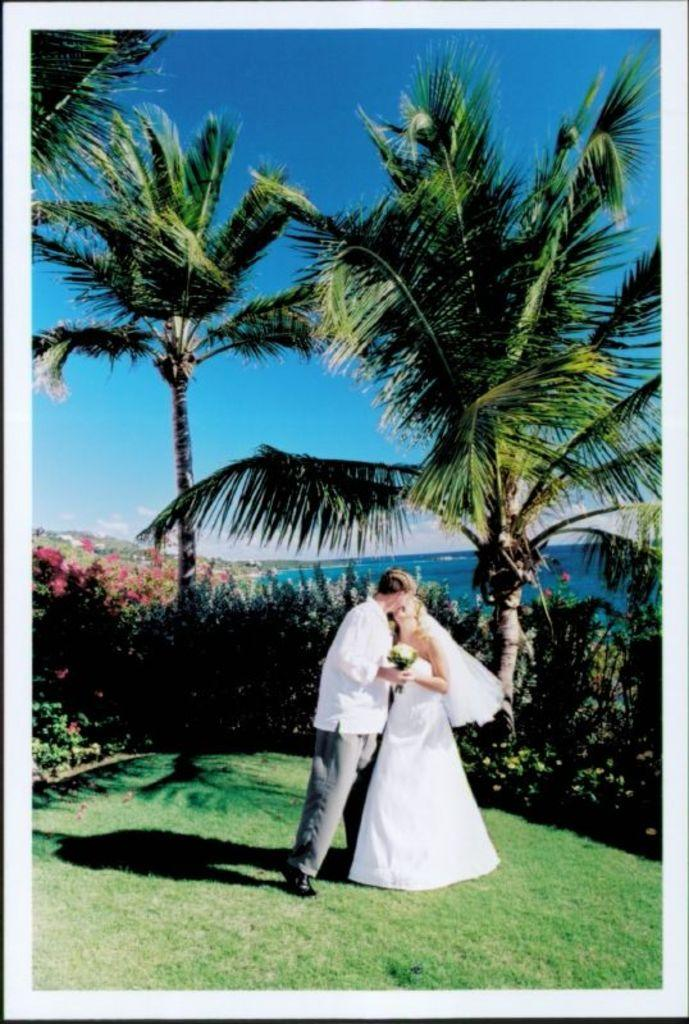What is happening between the couples in the image? The couples are kissing in the image. What can be seen in the background of the image? There are plants, trees, and a sea in the background of the image. What is the color of the sky in the image? The sky is blue in the image. How many times does the volleyball get hit in the image? There is no volleyball present in the image, so it cannot be determined how many times it would be hit. 